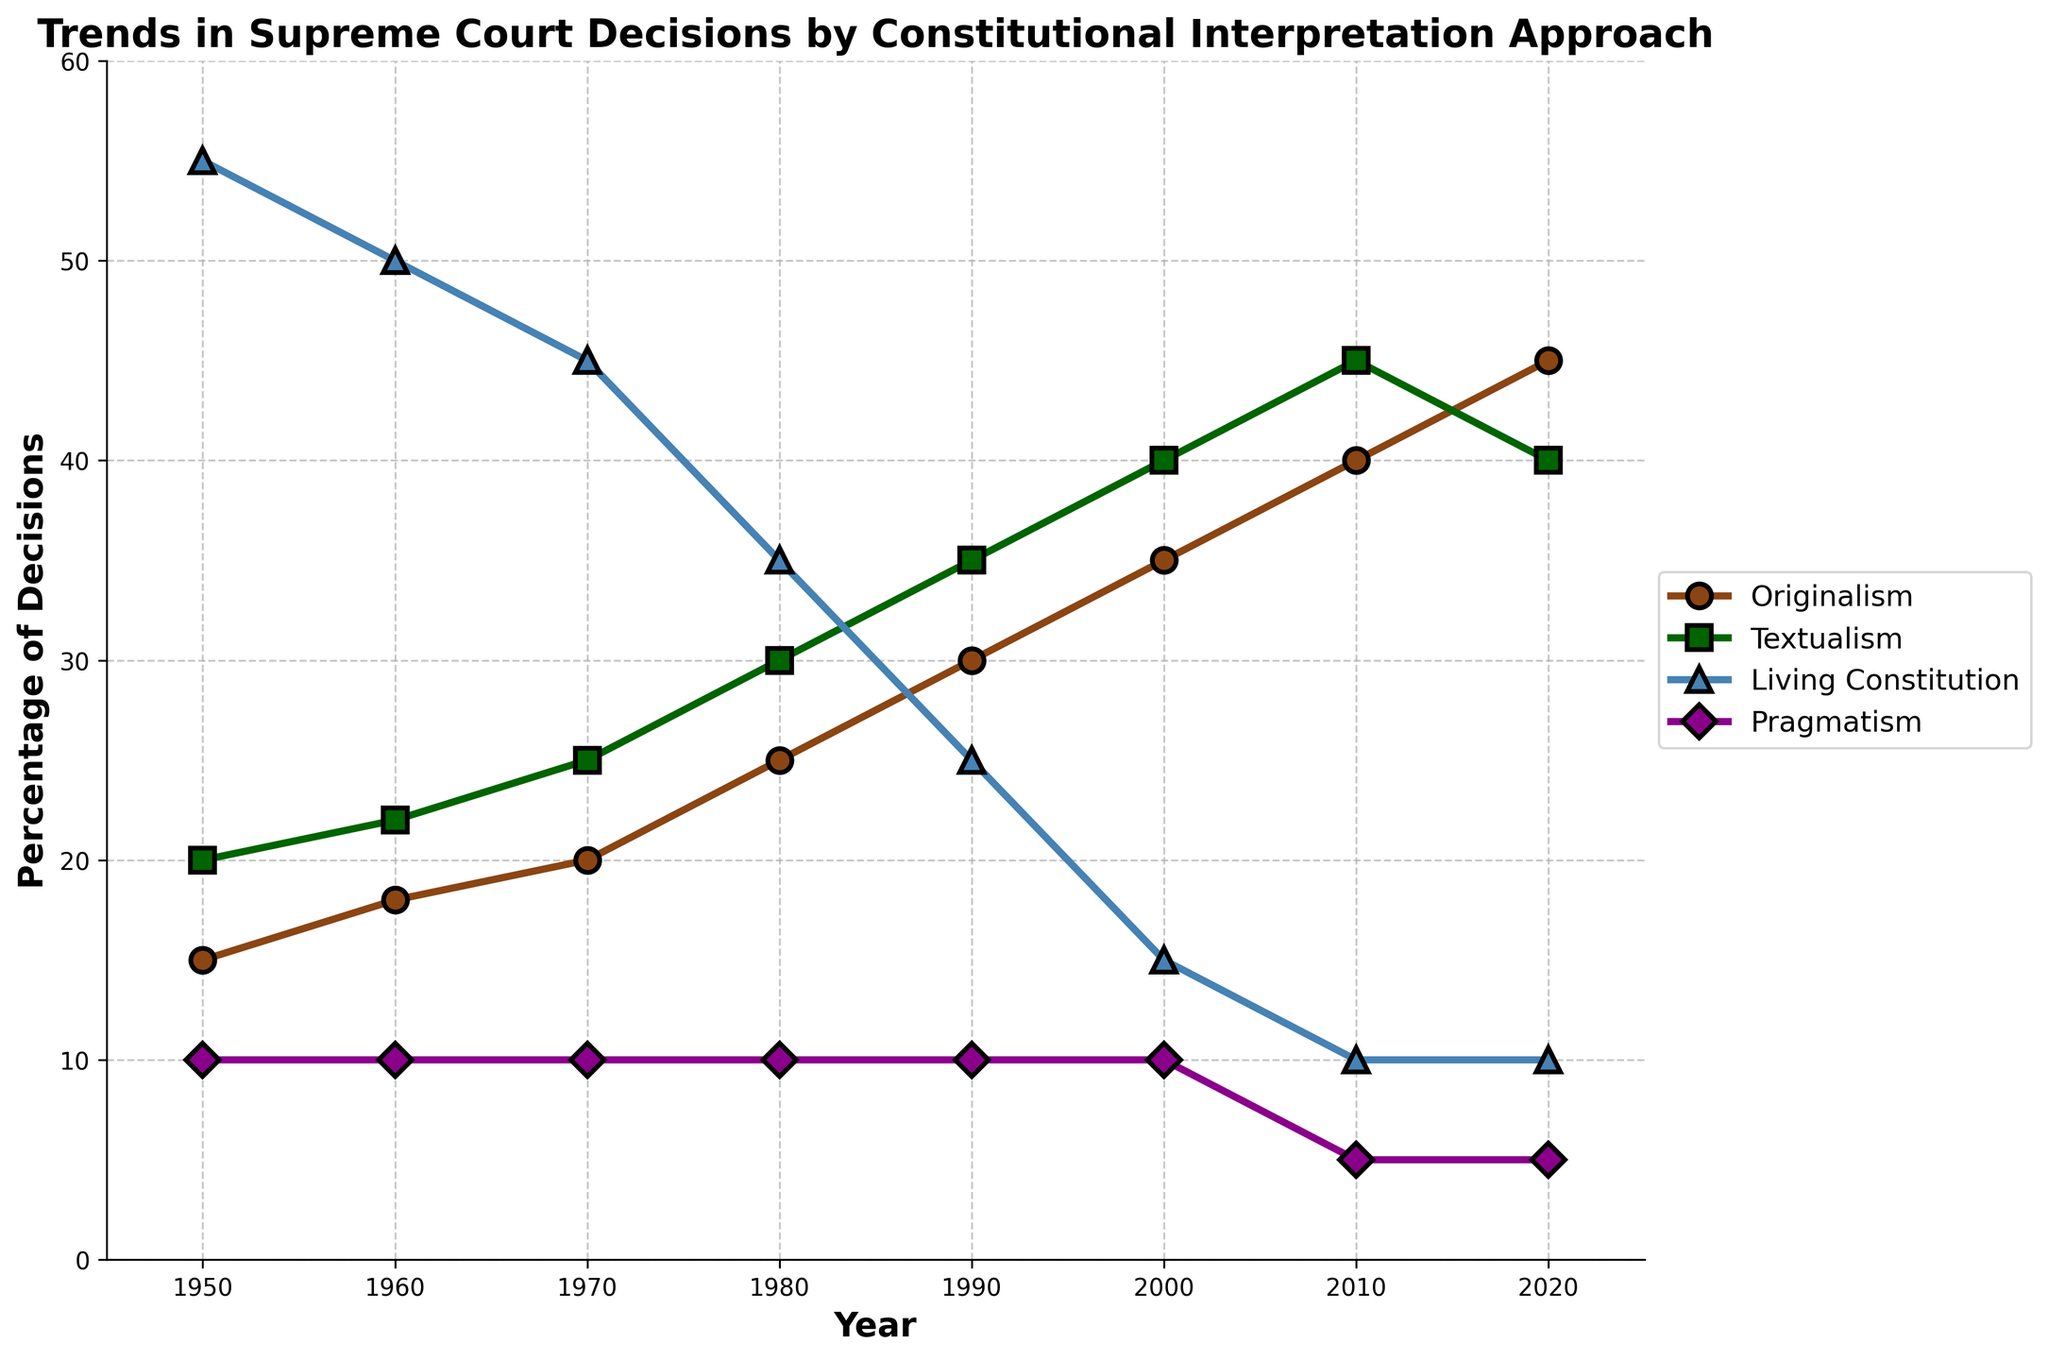What was the percentage increase in Originalism from 1950 to 2020? The percentage of decisions based on Originalism in 1950 was 15%. In 2020, it was 45%. The increase is 45% - 15% = 30%.
Answer: 30% In which decade did Textualism see the highest increase in its percentage of decisions? From the data, we see Textualism increasing over each decade. The changes are: 1950-1960 = 2%, 1960-1970 = 3%, 1970-1980 = 5%, 1980-1990 = 5%, 1990-2000 = 5%, 2000-2010 = 5%, 2010-2020 = -5%. The highest increase is 5% in the decades 1970-1980, 1980-1990, 1990-2000, and 2000-2010.
Answer: 1970 to 1980 Which interpretative approach had the most significant decline between 1950 and 2020? Originalism increased, Textualism increased, Living Constitution decreased from 55% to 10%, and Pragmatism remained stable. Living Constitution decreased by 45%, which is the most significant decline.
Answer: Living Constitution In 2020, which two approaches had the same percentage of decisions? By looking at the data for 2020, both Living Constitution and Pragmatism had 10% of the decisions.
Answer: Living Constitution and Pragmatism What is the average percentage of Living Constitution decisions between 1960 and 2000? The percentages for Living Constitution from 1960 to 2000 are: 50, 45, 35, 25, and 15. Sum these values: 50 + 45 + 35 + 25 + 15 = 170. There are 5 data points, so the average is 170 / 5 = 34%.
Answer: 34% Among the four interpretative approaches, which is the least prevalent in 2010? In 2010, the data shows that Pragmatism has 5%, which is the least compared to Originalism (40%), Textualism (45%), and Living Constitution (10%).
Answer: Pragmatism By how much did the percentage of Textualism exceed that of Originalism in the year 2000? In 2000, Textualism was 40% while Originalism was 35%. The difference is 40% - 35% = 5%.
Answer: 5% Compare the rate of increase in Originalism between 1950-1970 and 2000-2020. Which period saw a larger increase? From 1950-1970, Originalism increased from 15% to 20%, an increase of 5%. From 2000-2020, it increased from 35% to 45%, an increase of 10%. The period 2000-2020 saw a larger increase.
Answer: 2000-2020 Which approach had a constant percentage throughout the entire period? Reviewing all years, Pragmatism remains constant at 10%, with a slight dip to 5% in the last two decades. None remain constant throughout the entire period.
Answer: None What is the total sum of percentages for all approaches in the year 1980? For 1980, the percentages are: Originalism 25%, Textualism 30%, Living Constitution 35%, and Pragmatism 10%. Summing them gives: 25% + 30% + 35% + 10% = 100%.
Answer: 100% 